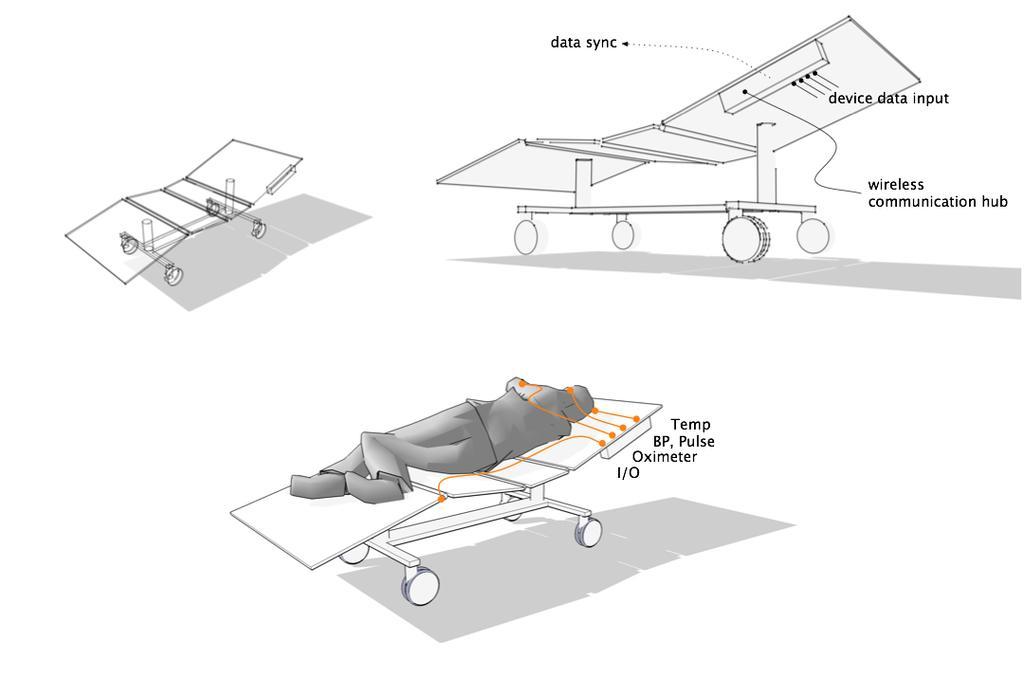Describe this image in one or two sentences. In the center of the image we can see some drawing, in which we can see one person lying on the wheel bed. And we can see two more wheel beds and we can see some text. 